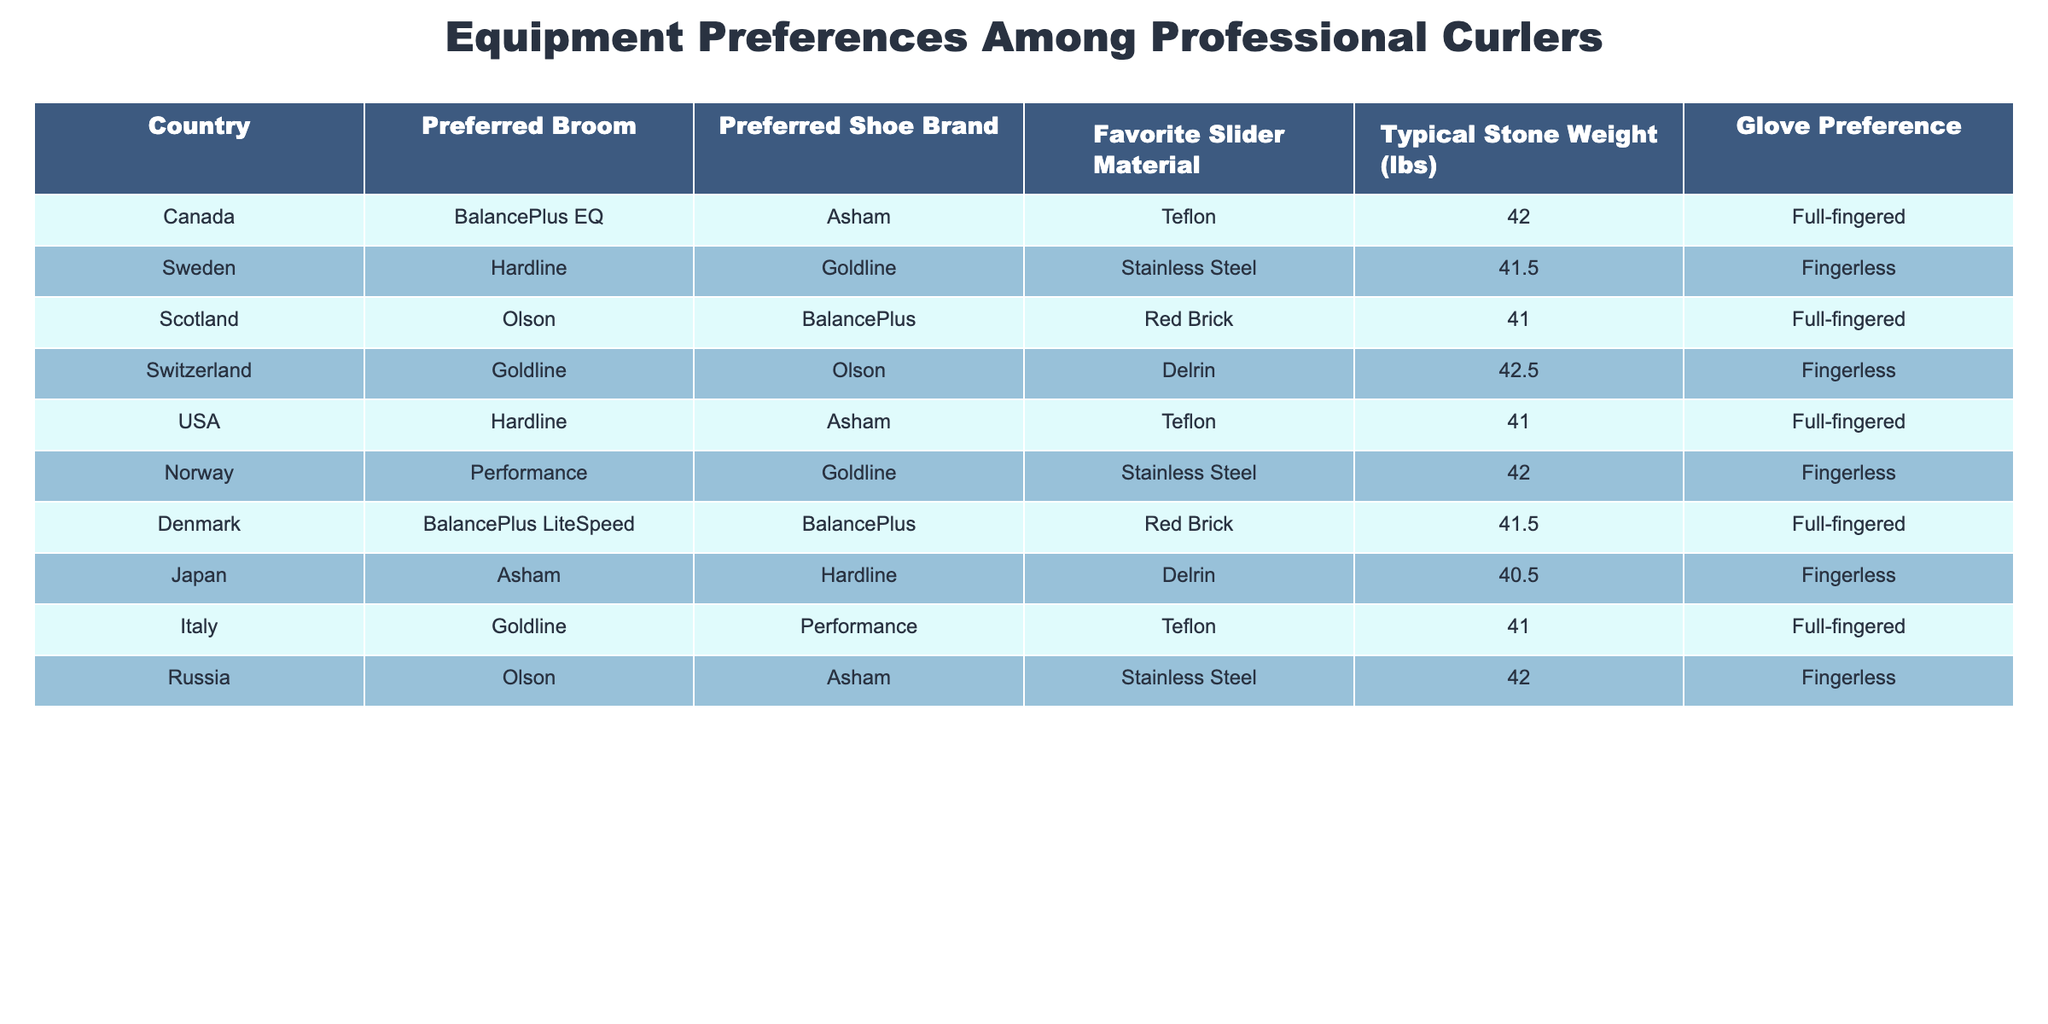What is the preferred broom of professional curlers from Canada? The table indicates that the preferred broom for Canada is "BalancePlus EQ".
Answer: BalancePlus EQ Which country prefers "Goldline" as their preferred shoe brand? From the table, we can see that both Switzerland and Italy prefer "Goldline" as their shoe brand.
Answer: Switzerland, Italy What is the typical stone weight used by curlers from Japan? According to the table, the typical stone weight for Japan is provided as 40.5 lbs.
Answer: 40.5 lbs Is "Fingerless" glove preference more common than "Full-fingered" among the countries listed? In reviewing the table, there are 5 countries that have "Fingerless" as their glove preference (Sweden, Switzerland, Norway, Japan, Russia) compared to 5 countries preferring "Full-fingered" (Canada, Scotland, USA, Denmark, Italy). Therefore, it is not common as both preferences are equal.
Answer: No What is the average typical stone weight of the countries that prefer "Teflon" as their favorite slider material? The countries that prefer "Teflon" are Canada, USA, and Italy, with respective stone weights of 42, 41, and 41 lbs. Thus, the average weight is calculated as (42 + 41 + 41) / 3 = 41.33 lbs.
Answer: 41.33 lbs Which country has the highest typical stone weight and what is that weight? Upon examination of the table, Switzerland has the highest typical stone weight of 42.5 lbs.
Answer: 42.5 lbs Do curlers from Norway use "Asham" as their preferred shoe brand? The data shows that Norway's preferred shoe brand is "Goldline", not "Asham". Therefore, the answer is no.
Answer: No How many countries listed prefer "Delrin" as their favorite slider material? The countries preferring "Delrin" are Switzerland and Japan. Counting them gives a total of 2 countries.
Answer: 2 